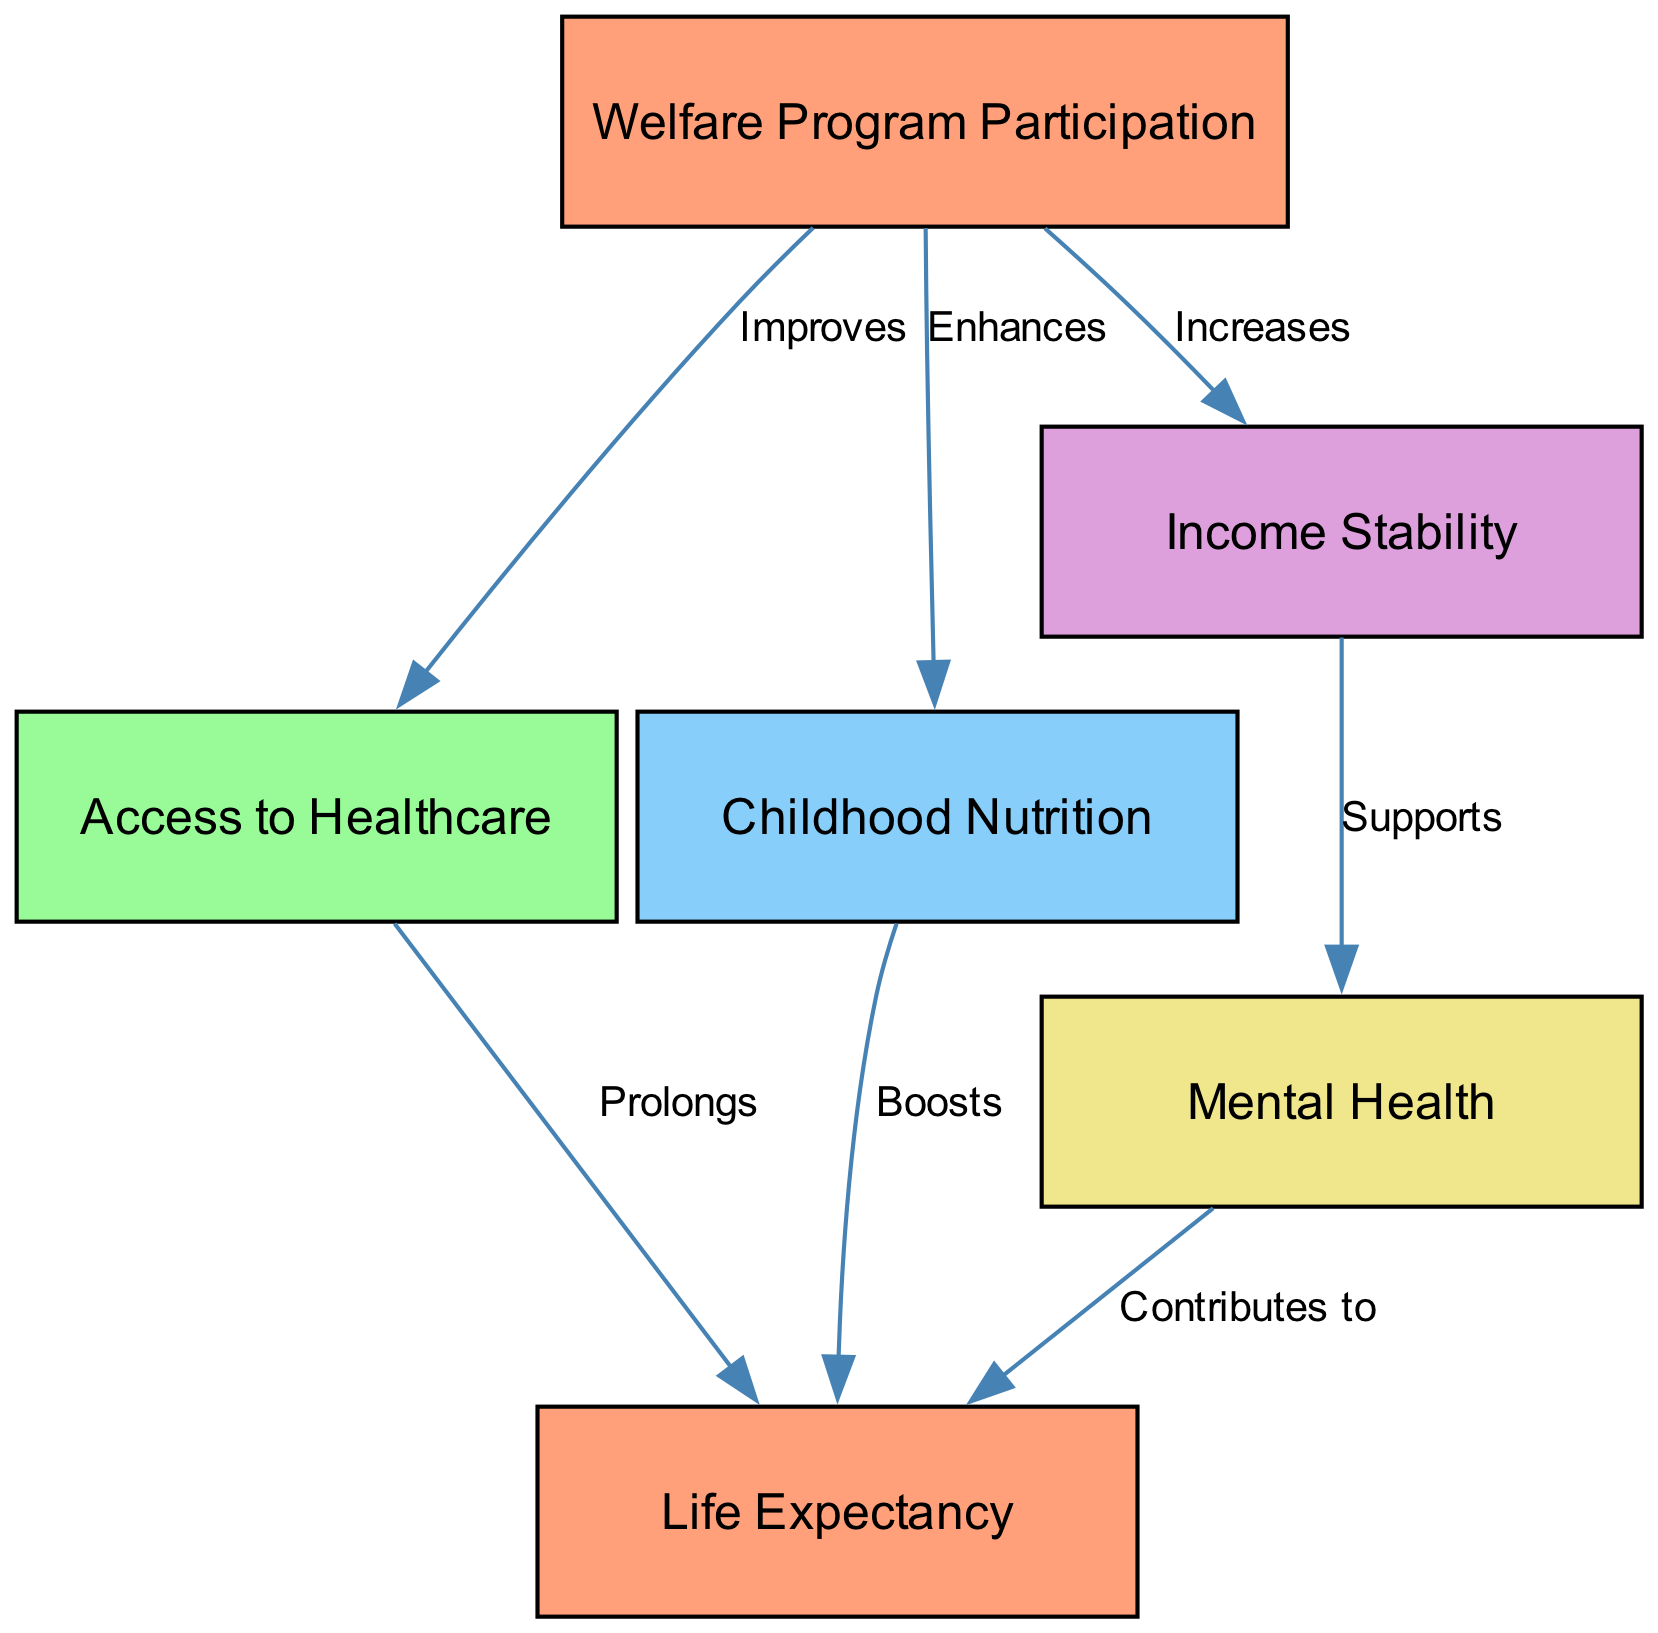What are the primary health indicators influenced by welfare program participation? According to the diagram, the primary health indicators influenced by welfare program participation are access to healthcare, childhood nutrition, and life expectancy. This is shown by the direct edges connecting welfare programs to these indicators.
Answer: Access to Healthcare, Childhood Nutrition, Life Expectancy How many nodes are present in the diagram? The diagram contains six nodes: welfare programs, access to healthcare, childhood nutrition, income stability, mental health, and life expectancy. By counting each unique node listed, the total is established.
Answer: 6 What does welfare program participation enhance? Welfare program participation enhances childhood nutrition, as indicated by the directed edge from welfare programs to childhood nutrition labeled "Enhances."
Answer: Childhood Nutrition Which indicator is supported by income stability? Income stability supports mental health, as shown by the edge leading from income stability to mental health marked "Supports."
Answer: Mental Health What is the final health outcome linked to access to healthcare? Access to healthcare contributes to the final health outcome of life expectancy, as demonstrated by the directed edge from access to healthcare to life expectancy labeled "Prolongs."
Answer: Life Expectancy Which two health indicators directly boost life expectancy? The two health indicators that directly boost life expectancy are childhood nutrition and access to healthcare, as both are connected by edges leading to life expectancy with labels "Boosts" and "Prolongs," respectively.
Answer: Childhood Nutrition, Access to Healthcare If income stability increases, what specific health outcome may improve as a result? If income stability increases, mental health may improve as a result, based on the diagram's depiction of the relationship where income stability supports mental health.
Answer: Mental Health What role does mental health play concerning life expectancy? Mental health contributes to life expectancy, indicated by the edge labeled "Contributes to" connecting mental health to life expectancy in the diagram.
Answer: Contributes to Which node does not have any incoming edges? The node that does not have any incoming edges is welfare program participation, as it serves as the source node for various connections but has no edges directed toward it.
Answer: Welfare Program Participation 